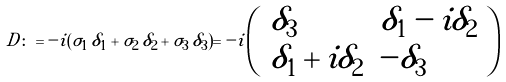Convert formula to latex. <formula><loc_0><loc_0><loc_500><loc_500>D \colon = - i ( \sigma _ { 1 } \, \delta _ { 1 } + \sigma _ { 2 } \, \delta _ { 2 } + \sigma _ { 3 } \, \delta _ { 3 } ) = - i \left ( \begin{array} { l l } { { \delta _ { 3 } } } & { { \delta _ { 1 } - i \delta _ { 2 } } } \\ { { \delta _ { 1 } + i \delta _ { 2 } } } & { { - \delta _ { 3 } } } \end{array} \right )</formula> 